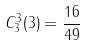Convert formula to latex. <formula><loc_0><loc_0><loc_500><loc_500>C _ { 3 } ^ { 3 } ( 3 ) = \frac { 1 6 } { 4 9 }</formula> 